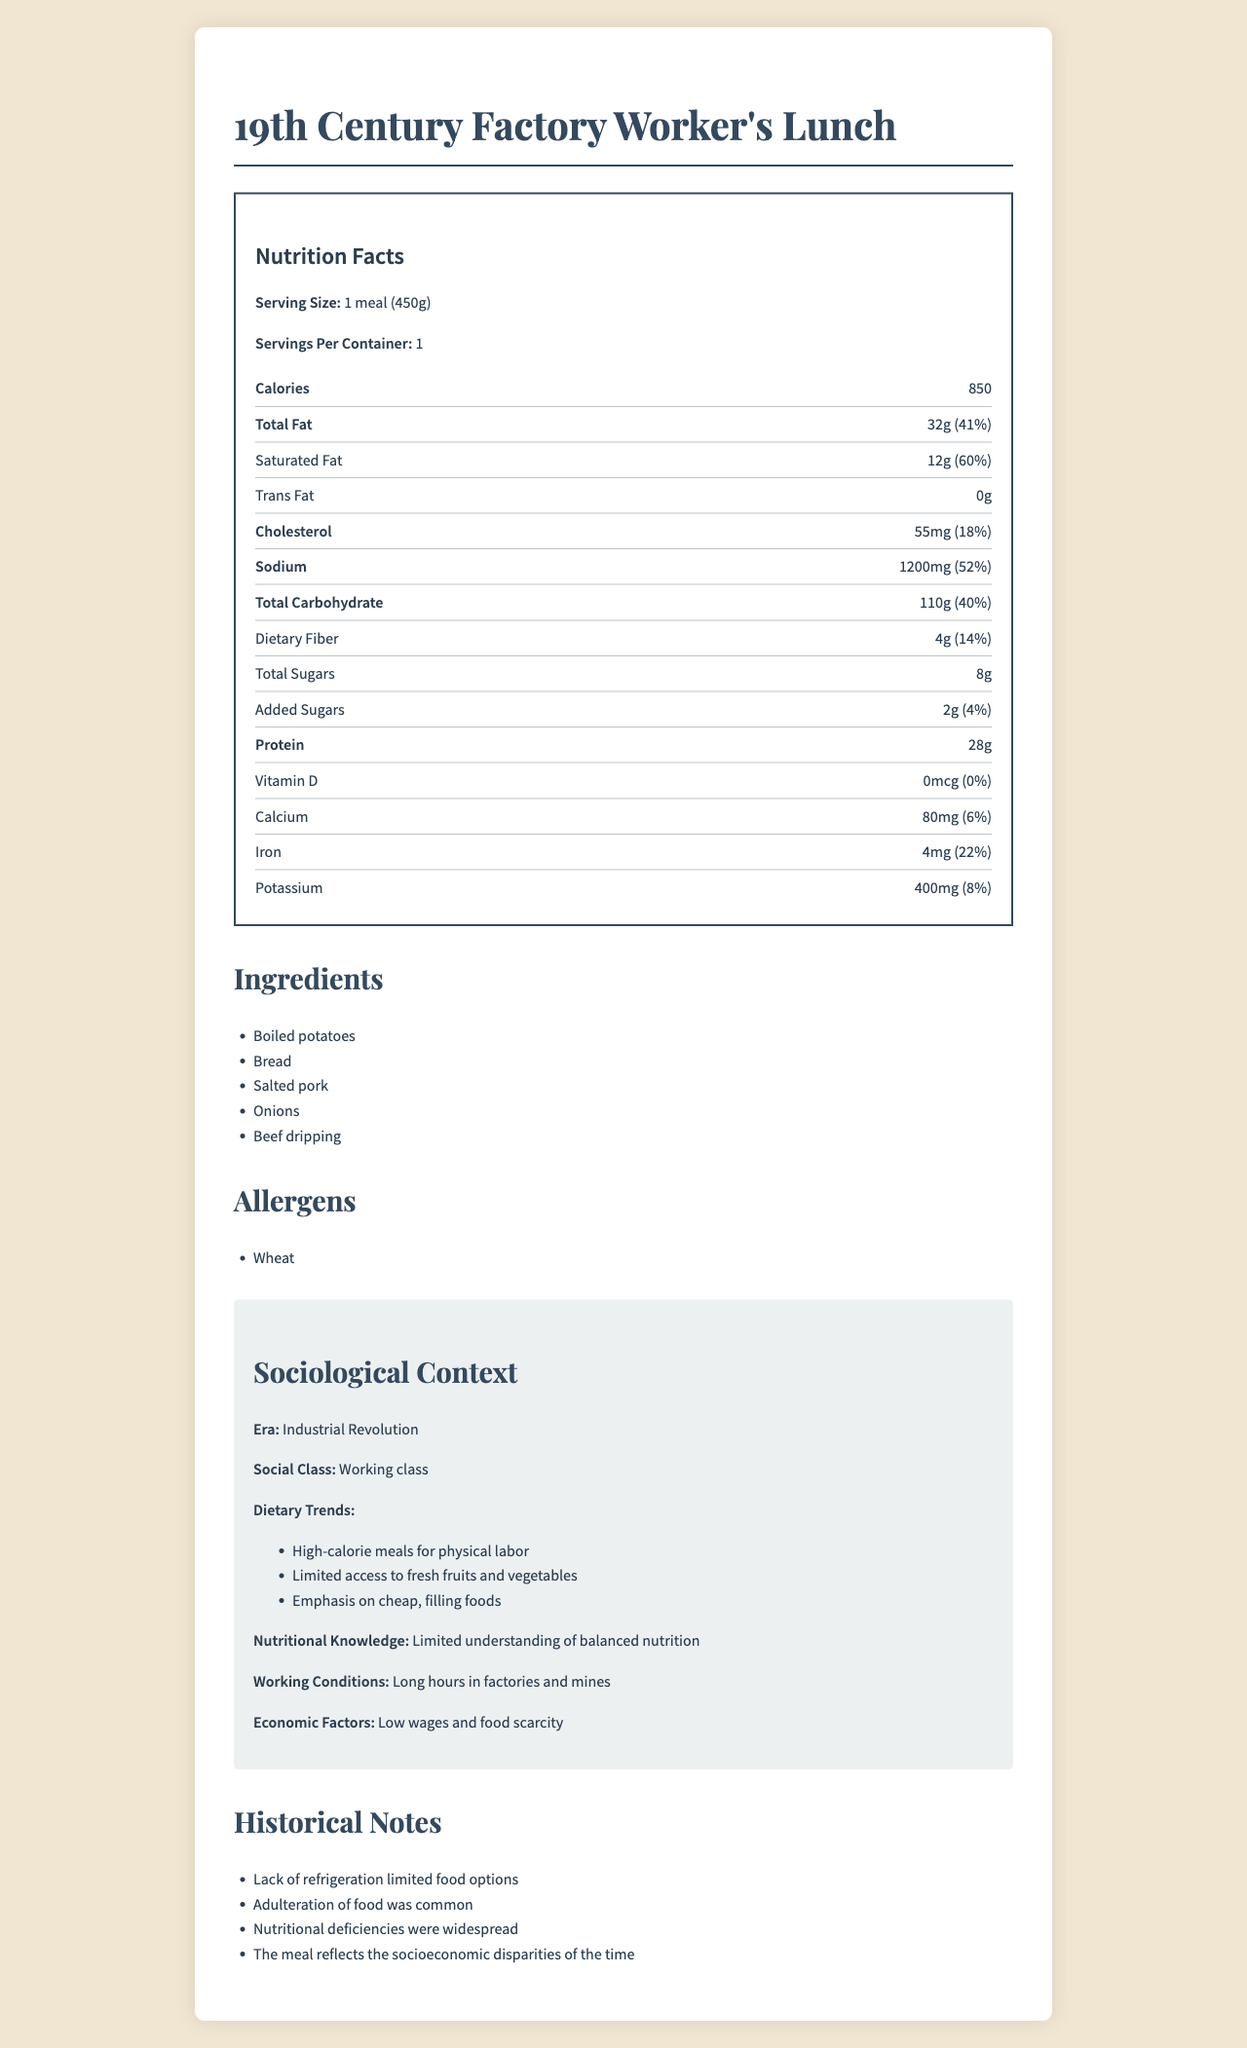What is the serving size for the 19th Century Factory Worker's Lunch? The serving size is clearly listed at the top of the Nutrition Facts label as "1 meal (450g)".
Answer: 1 meal (450g) How many calories per serving are in this meal? The Nutrition Facts label indicates that there are 850 calories per serving.
Answer: 850 calories What is the total fat content in grams and its percent daily value? The Nutrition Facts label states that the total fat content is 32 grams, which is 41% of the daily value.
Answer: 32g, 41% Which ingredient listed is a common allergen? The allergens section lists "Wheat" as a common allergen.
Answer: Wheat What percentage of daily iron intake does this meal provide? The Nutrition Facts label indicates that the iron content provides 22% of the daily value.
Answer: 22% Which of the following is NOT an ingredient in this meal? A. Potatoes B. Salted pork C. Cheese D. Onions The ingredients list includes "Boiled potatoes", "Bread", "Salted pork", and "Onions", but not "Cheese".
Answer: C. Cheese How much sodium is in this meal? A. 300mg B. 600mg C. 1200mg D. 1500mg The Nutrition Facts label lists the sodium content as 1200mg.
Answer: C. 1200mg Does this meal contain any Vitamin D? The Nutrition Facts label shows 0mcg of Vitamin D.
Answer: No Is the nutritional knowledge during the Industrial Revolution described as advanced and comprehensive? The sociological context mentions a "Limited understanding of balanced nutrition".
Answer: No Summarize the main idea of the document. The document includes nutritional information such as calories, fats, and vitamins, ingredients, allergens, and sociological context to help understand the dietary habits and nutritional limitations of factory workers during the Industrial Revolution.
Answer: The document provides a detailed Nutrition Facts label for a typical 19th Century Factory Worker's Lunch, highlighting its high calorie and fat content, and the lack of nutritional diversity. It places the meal in the context of the Industrial Revolution, noting the dietary trends, economic factors, and working conditions that influenced the food choices of the working class. What were the economic factors affecting food choices during the Industrial Revolution as mentioned in the document? The sociological context outlines that low wages and food scarcity were significant economic factors.
Answer: Low wages and food scarcity Can the information in the document determine if the meal was considered healthy by modern standards? The document provides nutritional details and context but does not include modern nutritional standards to compare.
Answer: Not enough information What was a common issue with food during the Industrial Revolution as mentioned in the historical notes? The historical notes state that "Adulteration of food was common" during the Industrial Revolution.
Answer: Adulteration of food 